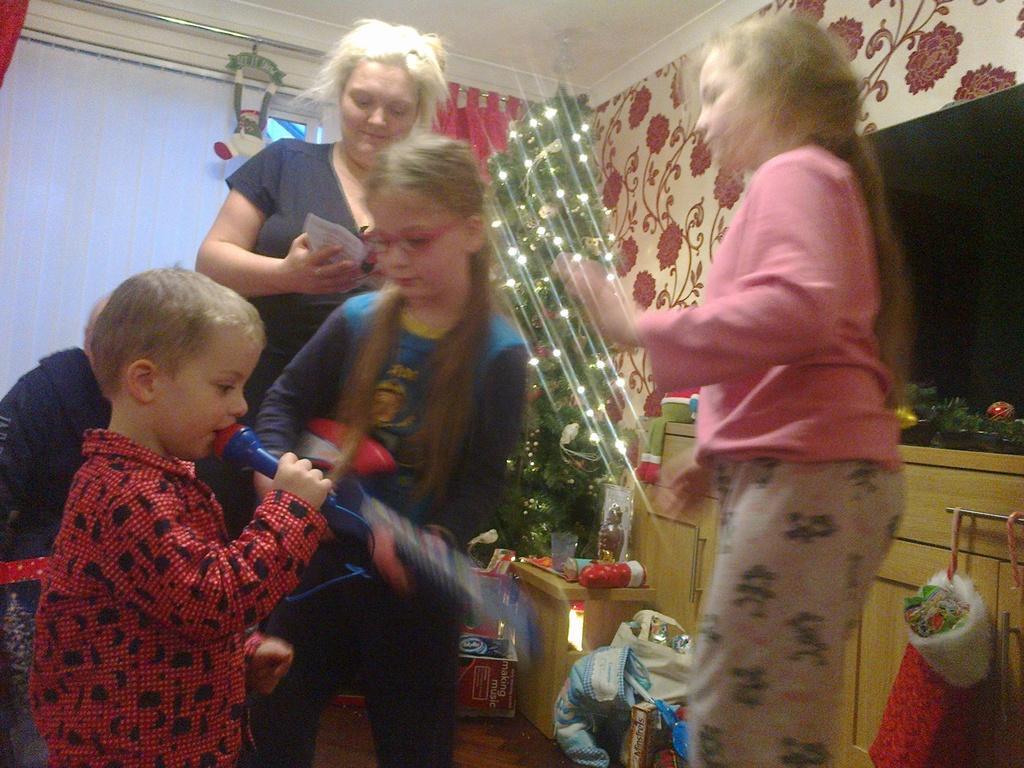How would you summarize this image in a sentence or two? In this image there is a kid holding a mic in his hand is singing, beside the kid there is a girl dancing and a girl holding a guitar, behind them there is a woman standing, behind them there is a Christmas tree and there are some objects on the floor and on the table, in the background of the image there is a television on the wall and there is a curtain. 